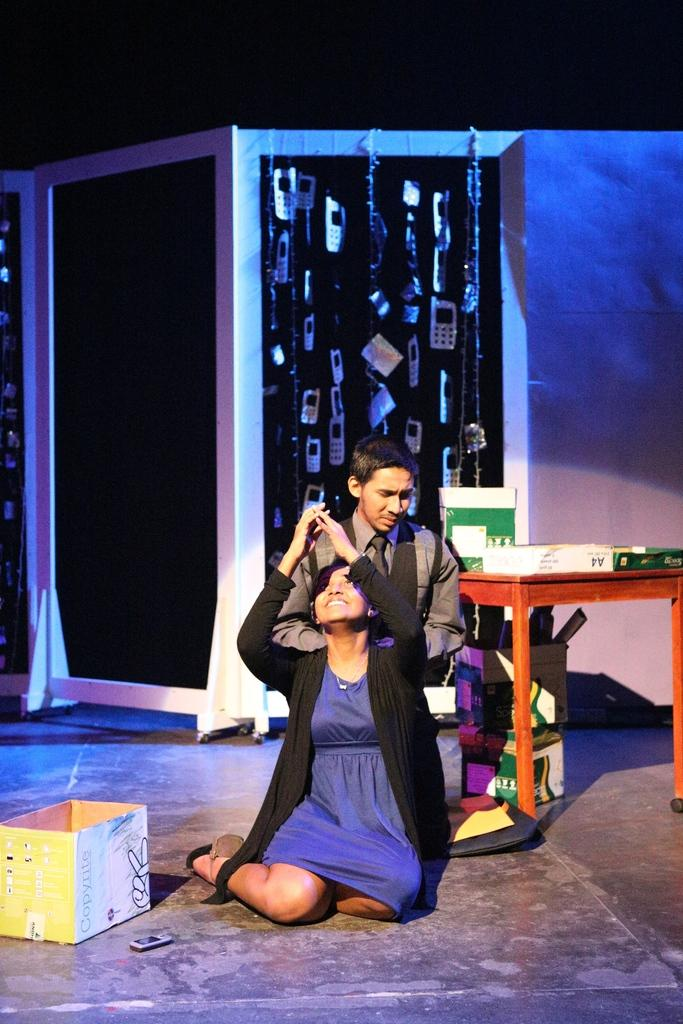How many people are present in the image? There are two people in the image. What object can be seen besides the people? There is a box in the image. What is the color of the wall in the image? There is a black wall in the image. What piece of furniture is present in the image? There is a table in the image. What type of bottle is being used by the pigs in the image? There are no pigs or bottles present in the image. 